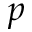Convert formula to latex. <formula><loc_0><loc_0><loc_500><loc_500>p</formula> 